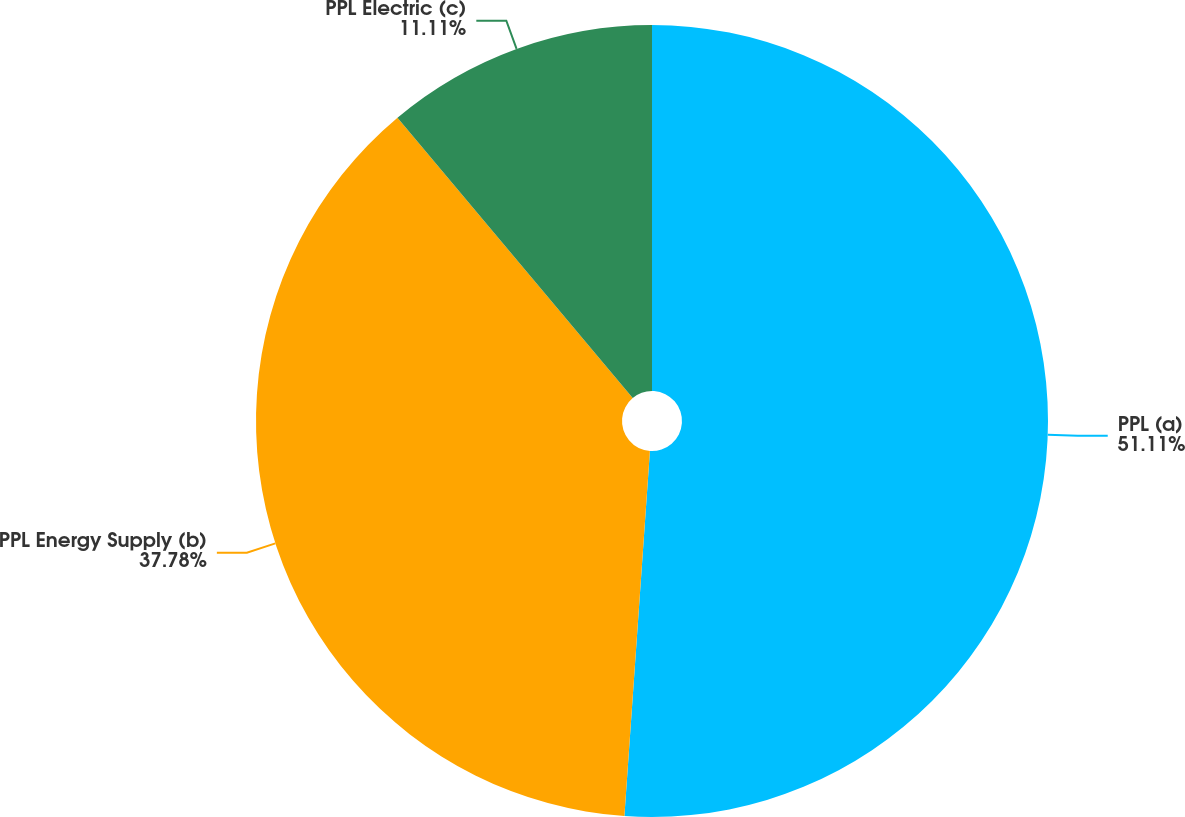<chart> <loc_0><loc_0><loc_500><loc_500><pie_chart><fcel>PPL (a)<fcel>PPL Energy Supply (b)<fcel>PPL Electric (c)<nl><fcel>51.11%<fcel>37.78%<fcel>11.11%<nl></chart> 